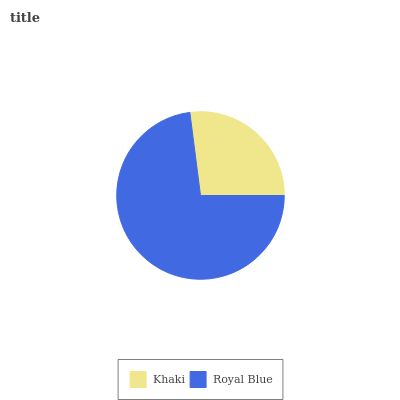Is Khaki the minimum?
Answer yes or no. Yes. Is Royal Blue the maximum?
Answer yes or no. Yes. Is Royal Blue the minimum?
Answer yes or no. No. Is Royal Blue greater than Khaki?
Answer yes or no. Yes. Is Khaki less than Royal Blue?
Answer yes or no. Yes. Is Khaki greater than Royal Blue?
Answer yes or no. No. Is Royal Blue less than Khaki?
Answer yes or no. No. Is Royal Blue the high median?
Answer yes or no. Yes. Is Khaki the low median?
Answer yes or no. Yes. Is Khaki the high median?
Answer yes or no. No. Is Royal Blue the low median?
Answer yes or no. No. 